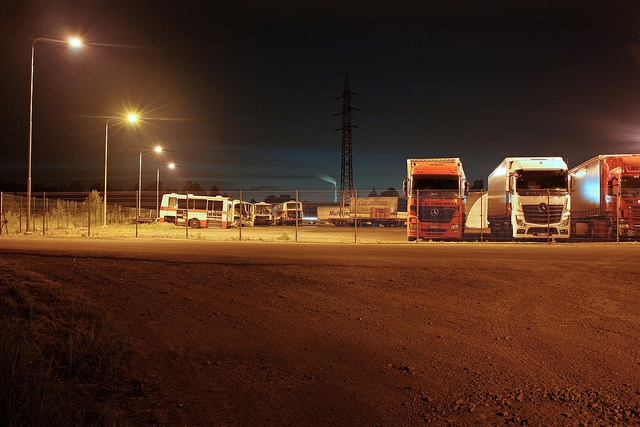Describe the objects in this image and their specific colors. I can see truck in black, maroon, tan, and brown tones, truck in black, maroon, and brown tones, bus in black, maroon, and brown tones, truck in black, maroon, brown, and red tones, and bus in black, maroon, khaki, brown, and tan tones in this image. 